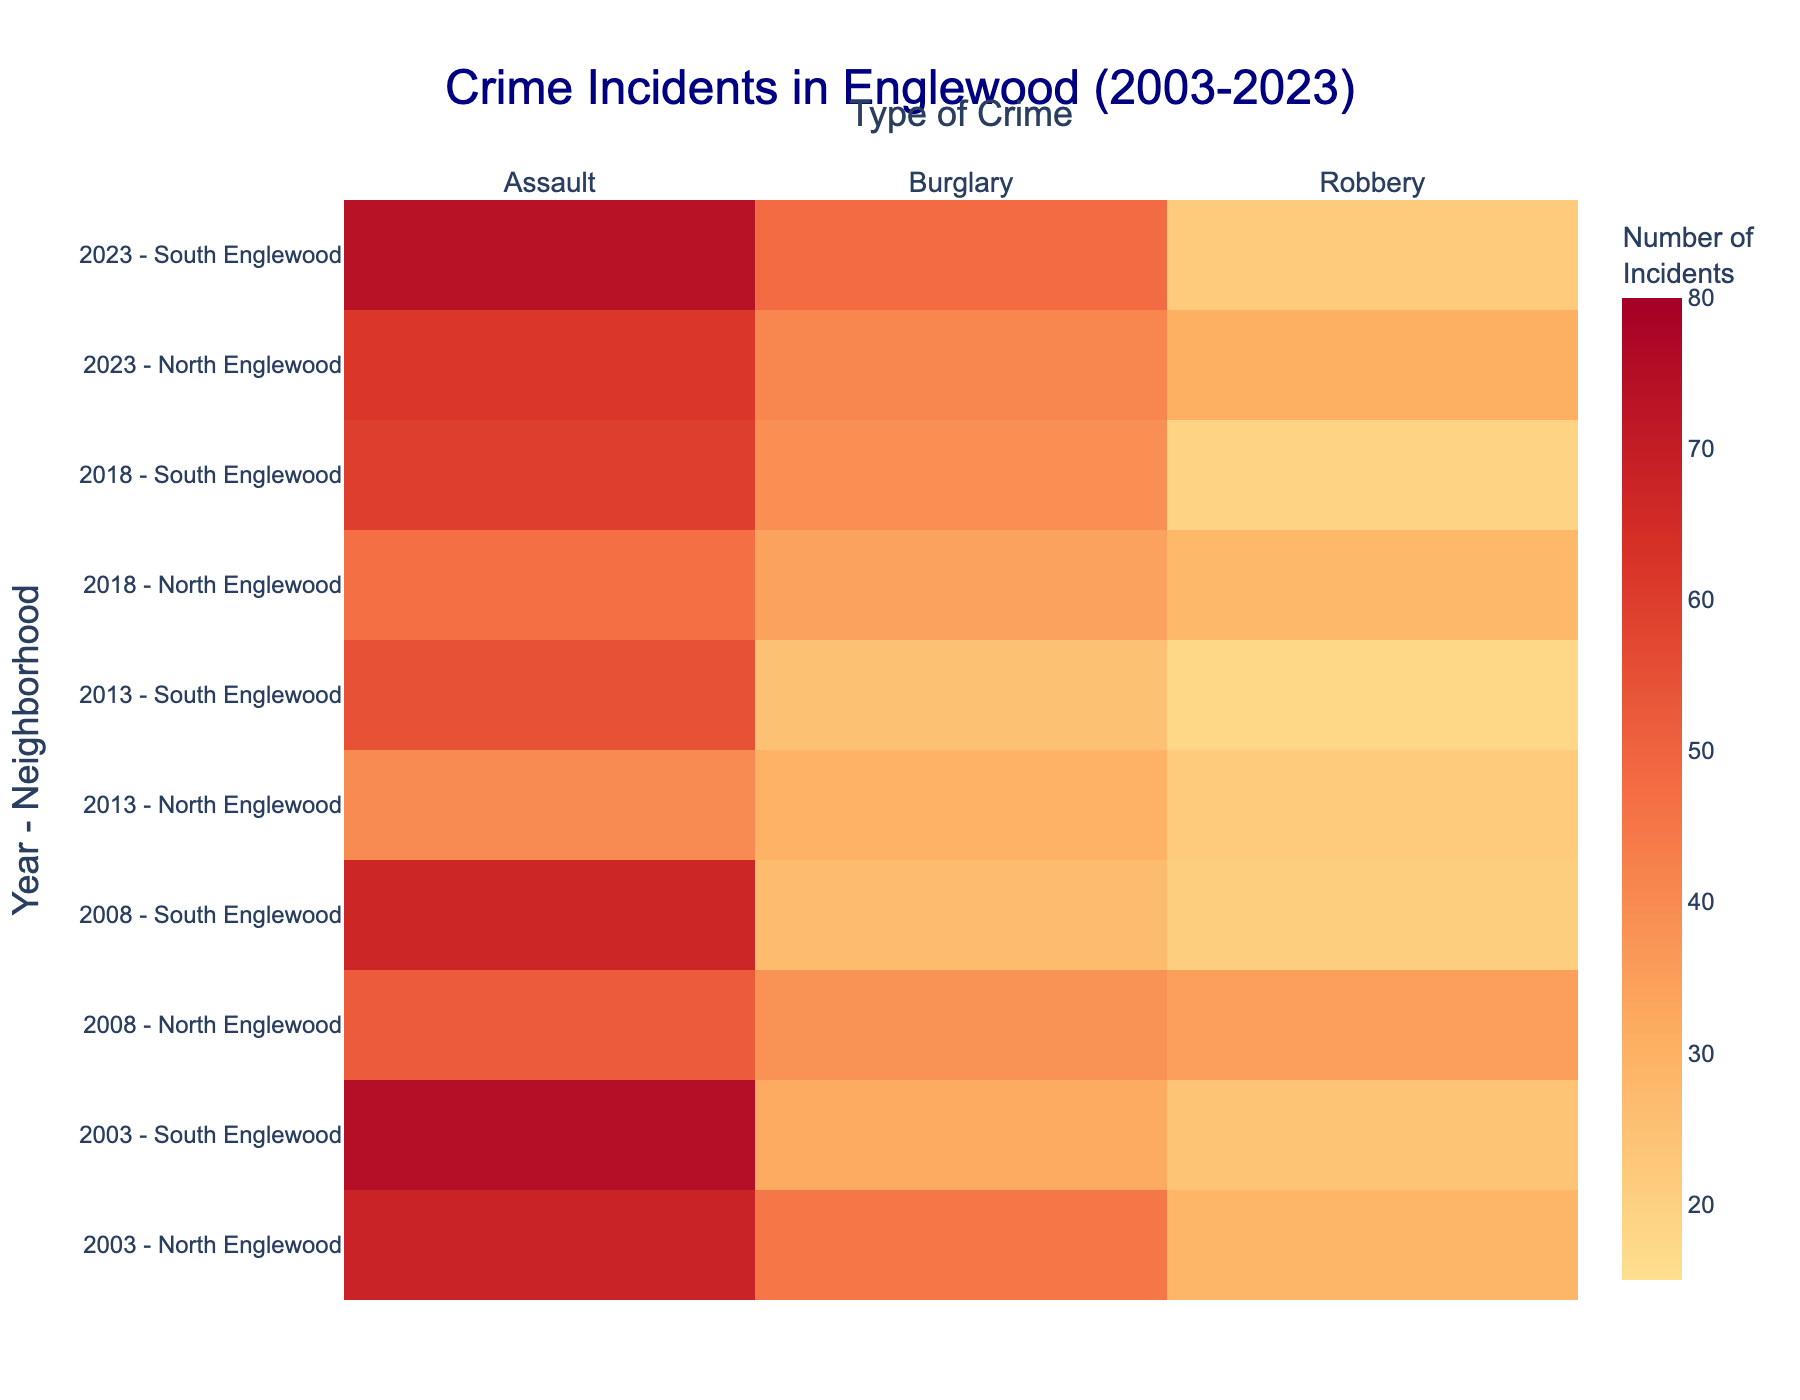What's the title of the heatmap? The title is displayed at the top center of the heatmap in a larger font size and indicates the context of the data presented.
Answer: "Crime Incidents in Englewood (2003-2023)" How many types of crimes are depicted in the heatmap? The x-axis labels of the heatmap list the different types of crimes included in the data.
Answer: Three Which year-neighborhood combination had the highest number of assault incidents? By inspecting the cells under the "Assault" column, one can identify the cell with the highest intensity (brightest or most saturated color). The corresponding y-axis label will provide the year-neighborhood combination.
Answer: "2023 - South Englewood" What's the total number of burglary incidents in North Englewood in the years provided? Add the values of burglary incidents for North Englewood across the listed years: 45 (2003), 38 (2008), 30 (2013), 34 (2018), and 41 (2023).
Answer: 188 Compare the number of robbery incidents in North Englewood in 2003 and 2023. Which year had more? Look at the cells corresponding to "2003 - North Englewood" and "2023 - North Englewood" for the robbery incidents, then compare the values.
Answer: 2023 Which type of crime remains the most consistent in its frequency over the years in South Englewood? By comparing the variation in color intensity for the different crimes in South Englewood across the years, you can identify which crime type has the least variation.
Answer: Robbery Is there any year where both neighborhoods (North and South Englewood) had an equal number of burglary incidents? Check the cells for both neighborhoods in each year under the "Burglary" column to see if there are any matching values.
Answer: 2008 Calculate the average number of assault incidents in South Englewood over the sampled years. Add the number of assault incidents in South Englewood for each year (75, 67, 55, 60, 74) and then divide by the number of years (5).
Answer: 66.2 Which year observed the smallest difference in robbery incidents between North and South Englewood? Calculate the absolute difference in robbery incidents between the neighborhoods for each year and identify the year with the smallest difference.
Answer: 2018 